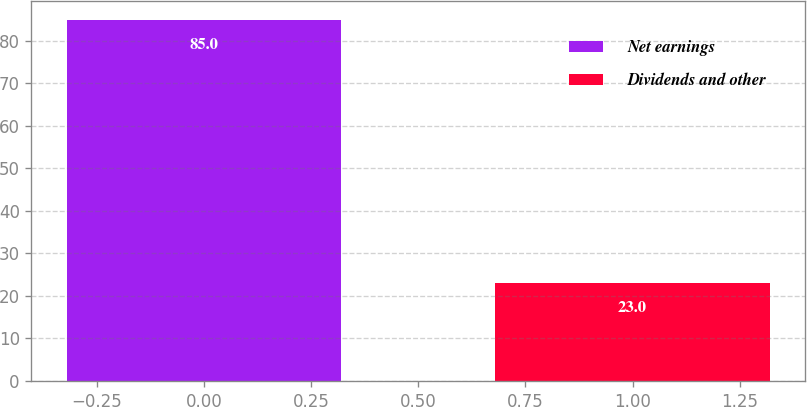<chart> <loc_0><loc_0><loc_500><loc_500><bar_chart><fcel>Net earnings<fcel>Dividends and other<nl><fcel>85<fcel>23<nl></chart> 